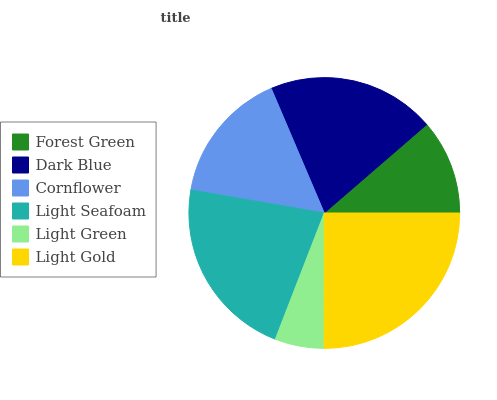Is Light Green the minimum?
Answer yes or no. Yes. Is Light Gold the maximum?
Answer yes or no. Yes. Is Dark Blue the minimum?
Answer yes or no. No. Is Dark Blue the maximum?
Answer yes or no. No. Is Dark Blue greater than Forest Green?
Answer yes or no. Yes. Is Forest Green less than Dark Blue?
Answer yes or no. Yes. Is Forest Green greater than Dark Blue?
Answer yes or no. No. Is Dark Blue less than Forest Green?
Answer yes or no. No. Is Dark Blue the high median?
Answer yes or no. Yes. Is Cornflower the low median?
Answer yes or no. Yes. Is Light Gold the high median?
Answer yes or no. No. Is Forest Green the low median?
Answer yes or no. No. 